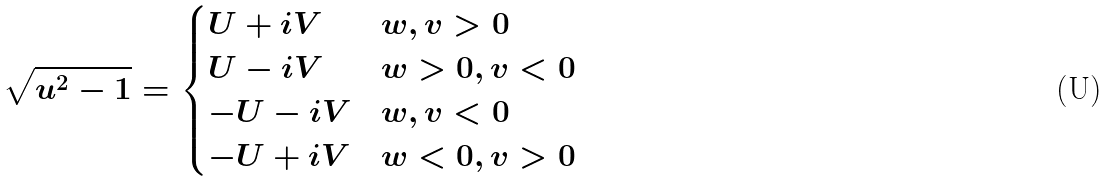<formula> <loc_0><loc_0><loc_500><loc_500>\sqrt { u ^ { 2 } - 1 } = \begin{cases} U + i V & w , v > 0 \\ U - i V & w > 0 , v < 0 \\ - U - i V & w , v < 0 \\ - U + i V & w < 0 , v > 0 \end{cases}</formula> 